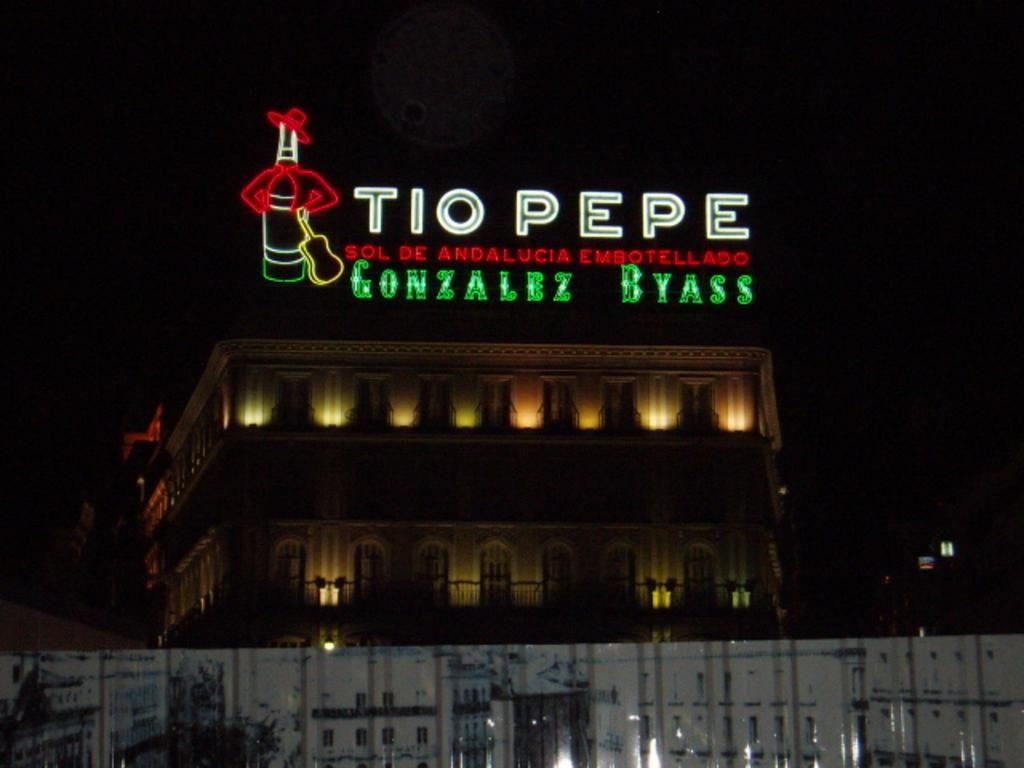What type of structure is present in the image? There is a building in the image. What feature can be observed on the building? The building has windows. What additional element is visible in the image? There is LED text visible in the image. How would you describe the overall appearance of the image? The background of the image is dark. What type of straw is being used to express anger in the image? There is no straw or expression of anger present in the image. 